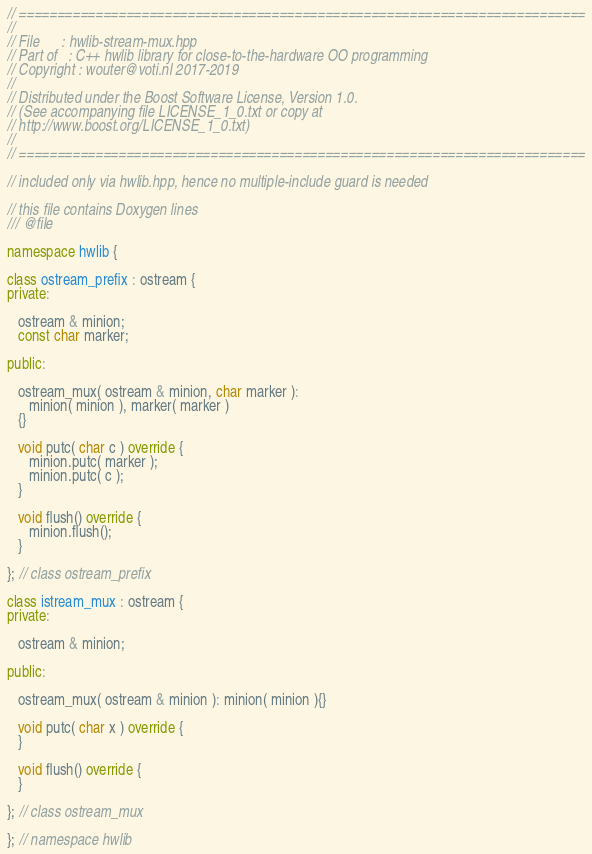<code> <loc_0><loc_0><loc_500><loc_500><_C++_>// ==========================================================================
//
// File      : hwlib-stream-mux.hpp
// Part of   : C++ hwlib library for close-to-the-hardware OO programming
// Copyright : wouter@voti.nl 2017-2019
//
// Distributed under the Boost Software License, Version 1.0.
// (See accompanying file LICENSE_1_0.txt or copy at 
// http://www.boost.org/LICENSE_1_0.txt)
//
// ==========================================================================

// included only via hwlib.hpp, hence no multiple-include guard is needed

// this file contains Doxygen lines
/// @file

namespace hwlib {

class ostream_prefix : ostream {
private:

   ostream & minion;
   const char marker;

public:

   ostream_mux( ostream & minion, char marker ): 
      minion( minion ), marker( marker )
   {}

   void putc( char c ) override {
      minion.putc( marker );
      minion.putc( c );
   }
 
   void flush() override {
      minion.flush();
   }

}; // class ostream_prefix

class istream_mux : ostream {
private:

   ostream & minion;

public:

   ostream_mux( ostream & minion ): minion( minion ){}

   void putc( char x ) override {
   }
 
   void flush() override {
   }

}; // class ostream_mux
   
}; // namespace hwlib
</code> 